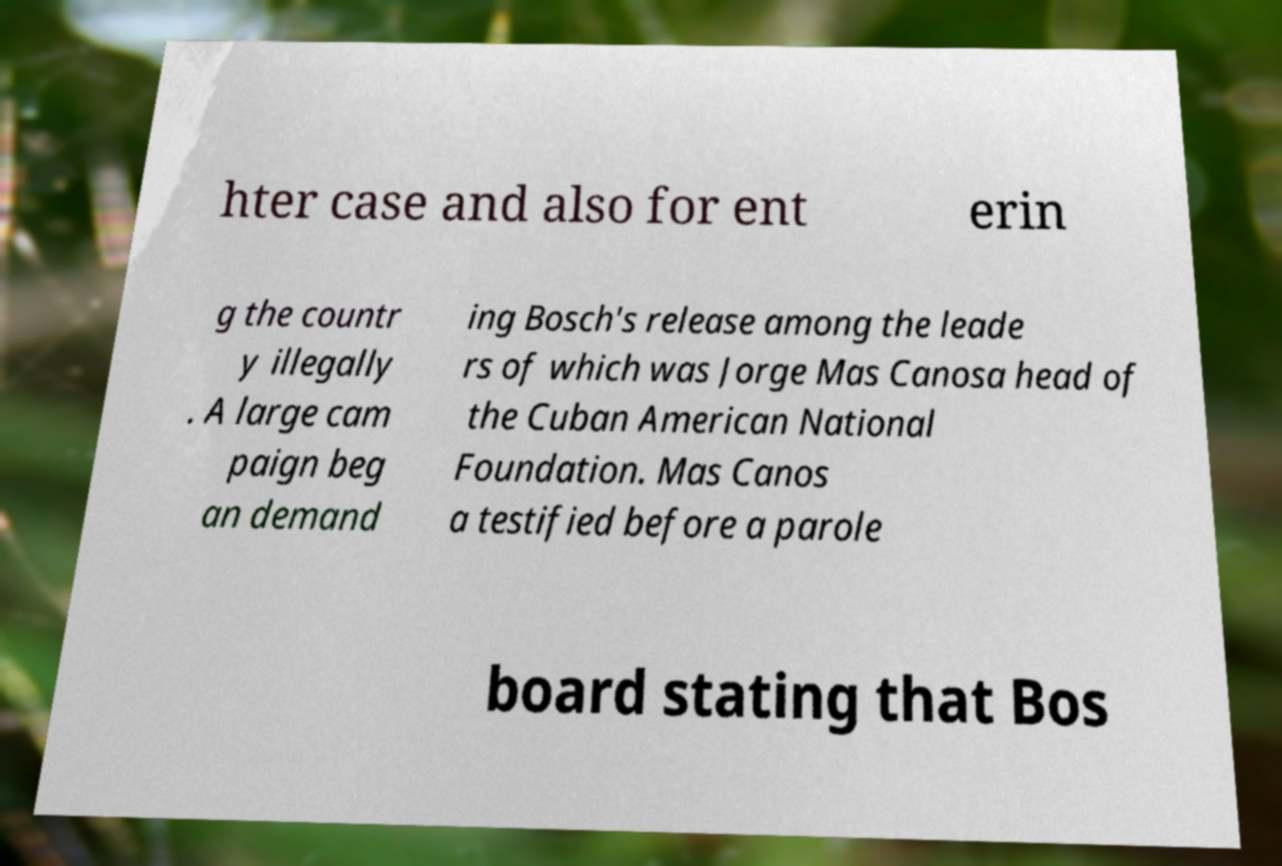Please read and relay the text visible in this image. What does it say? hter case and also for ent erin g the countr y illegally . A large cam paign beg an demand ing Bosch's release among the leade rs of which was Jorge Mas Canosa head of the Cuban American National Foundation. Mas Canos a testified before a parole board stating that Bos 